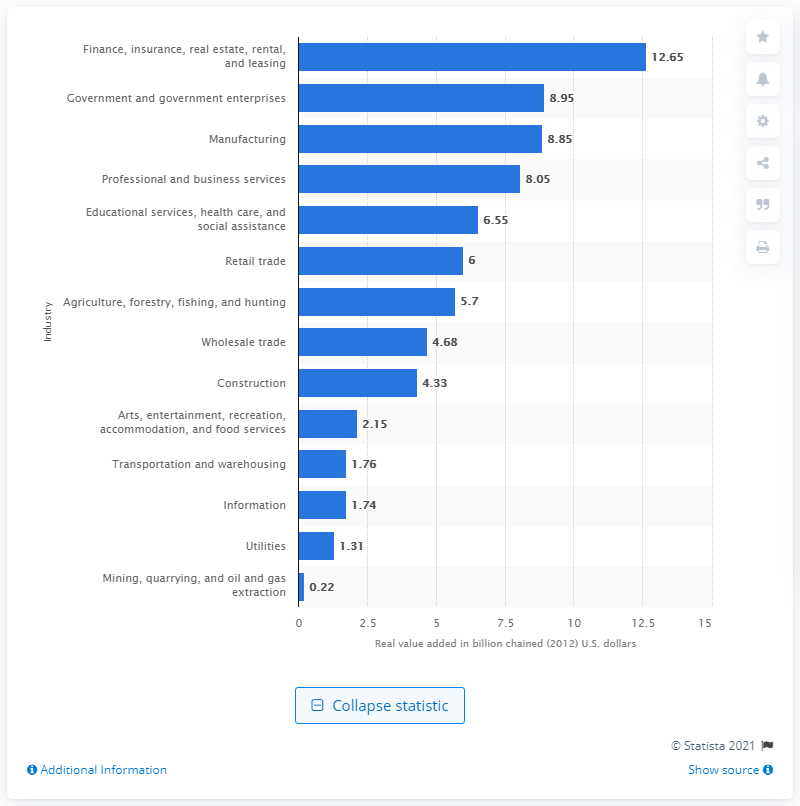Highlight a few significant elements in this photo. The finance, insurance, real estate, rental, and leasing industry contributed 12.65% to the gross domestic product of Idaho in 2012. 